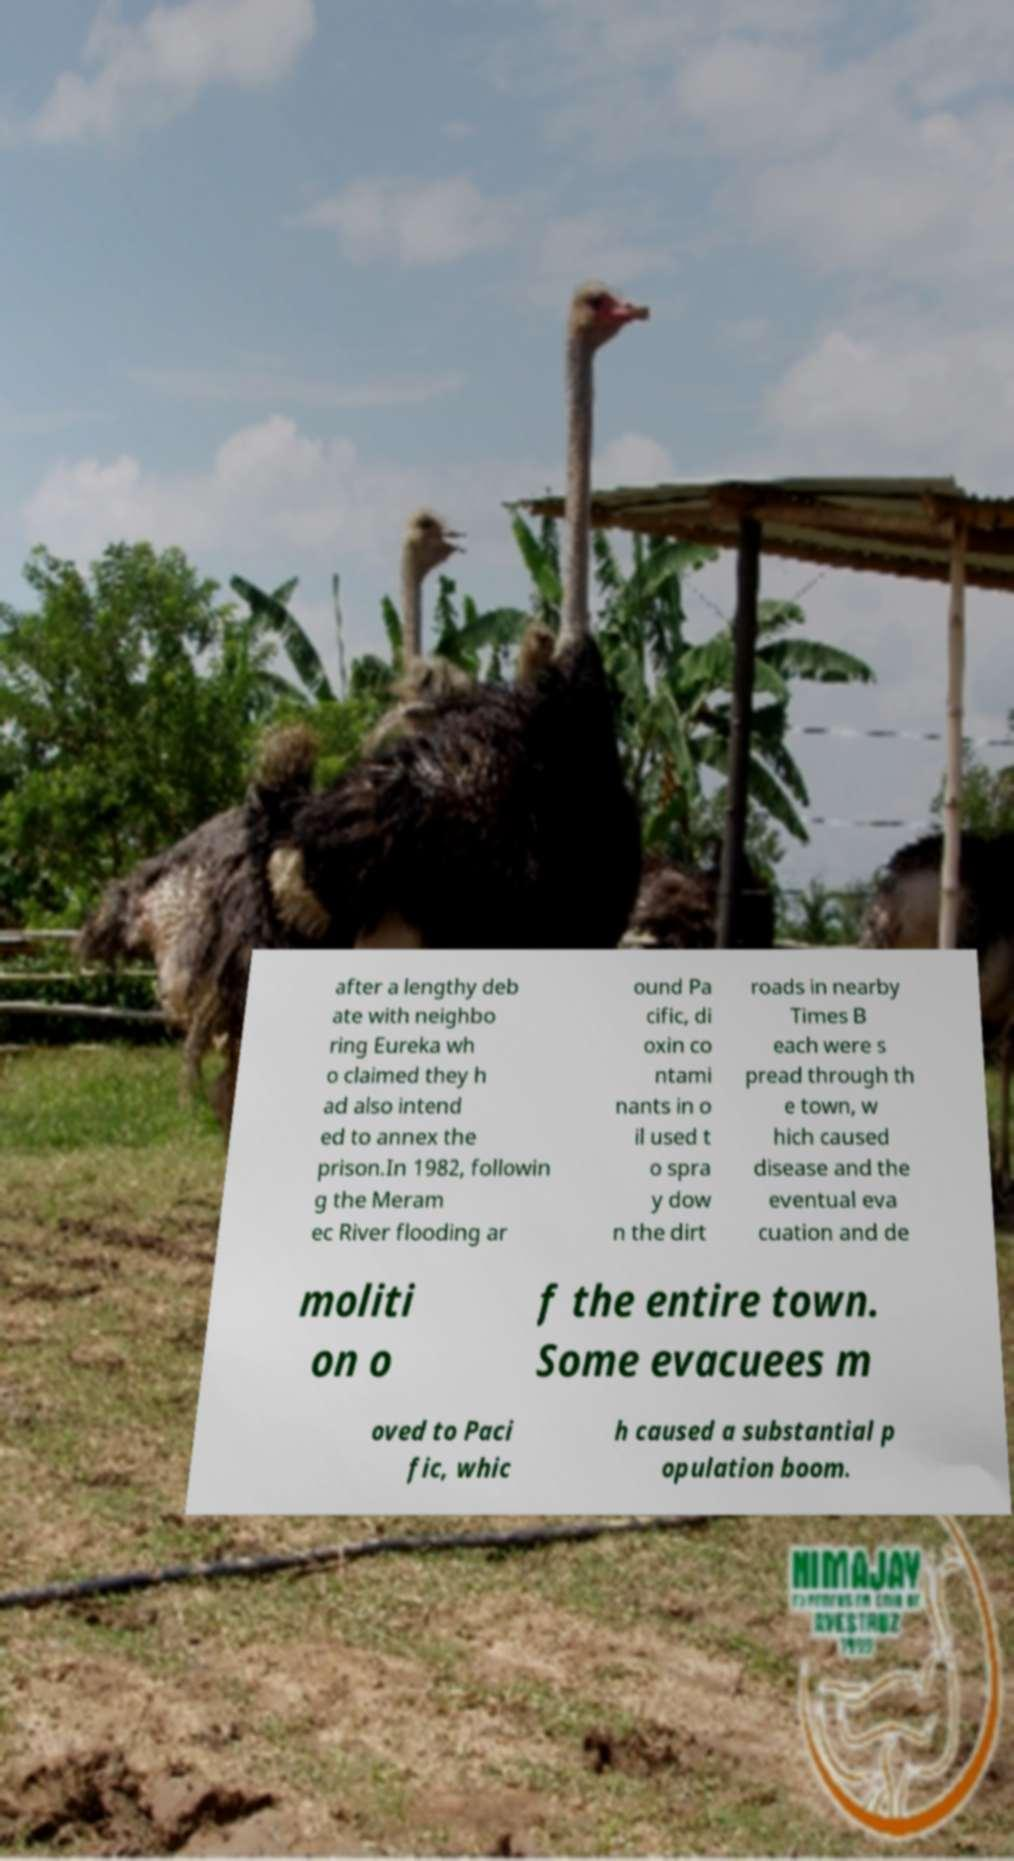I need the written content from this picture converted into text. Can you do that? after a lengthy deb ate with neighbo ring Eureka wh o claimed they h ad also intend ed to annex the prison.In 1982, followin g the Meram ec River flooding ar ound Pa cific, di oxin co ntami nants in o il used t o spra y dow n the dirt roads in nearby Times B each were s pread through th e town, w hich caused disease and the eventual eva cuation and de moliti on o f the entire town. Some evacuees m oved to Paci fic, whic h caused a substantial p opulation boom. 